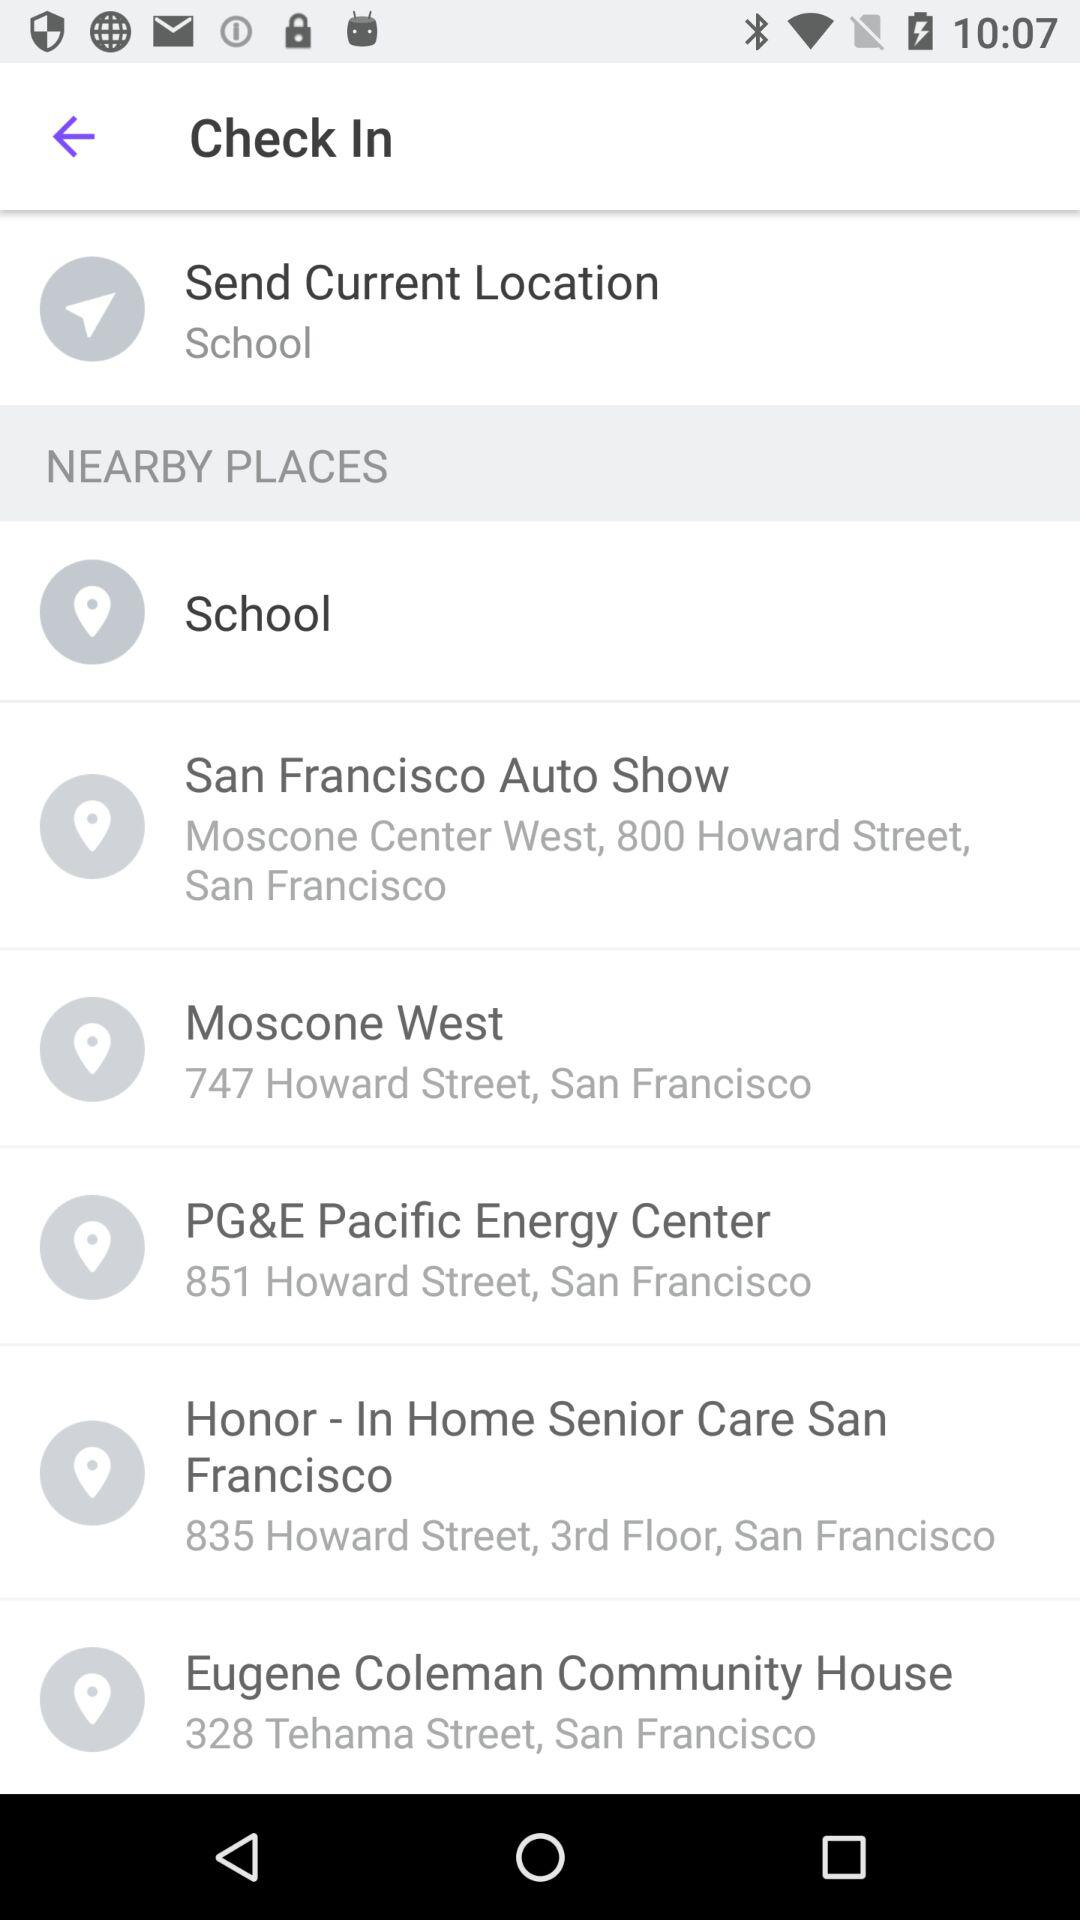What is the address of Moscone West? The address of Moscone West is 747 Howard Street, San Francisco. 